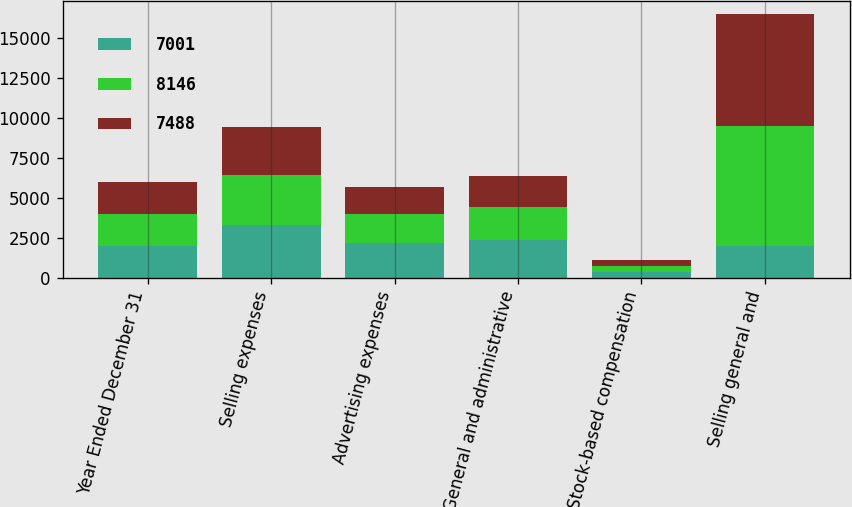Convert chart to OTSL. <chart><loc_0><loc_0><loc_500><loc_500><stacked_bar_chart><ecel><fcel>Year Ended December 31<fcel>Selling expenses<fcel>Advertising expenses<fcel>General and administrative<fcel>Stock-based compensation<fcel>Selling general and<nl><fcel>7001<fcel>2004<fcel>3296<fcel>2165<fcel>2340<fcel>345<fcel>2004<nl><fcel>8146<fcel>2003<fcel>3157<fcel>1822<fcel>2102<fcel>407<fcel>7488<nl><fcel>7488<fcel>2002<fcel>2978<fcel>1712<fcel>1946<fcel>365<fcel>7001<nl></chart> 